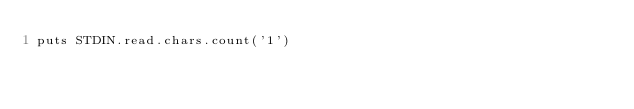<code> <loc_0><loc_0><loc_500><loc_500><_Ruby_>puts STDIN.read.chars.count('1')</code> 